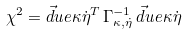Convert formula to latex. <formula><loc_0><loc_0><loc_500><loc_500>\chi ^ { 2 } = \vec { d } u e { \kappa } { \dot { \eta } } ^ { T } \, \Gamma _ { \kappa , \dot { \eta } } ^ { - 1 } \, \vec { d } u e { \kappa } { \dot { \eta } }</formula> 